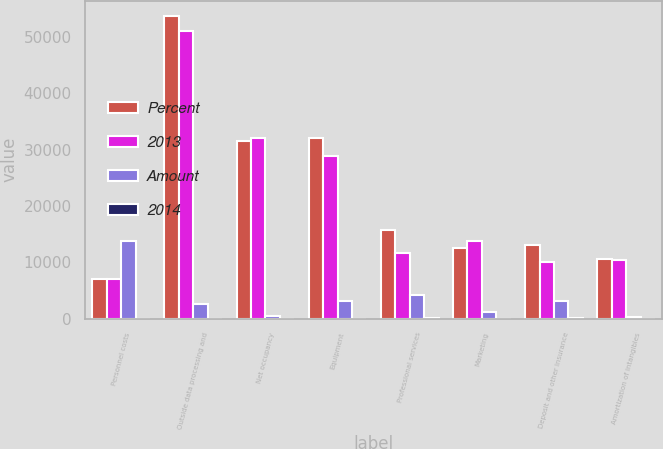Convert chart. <chart><loc_0><loc_0><loc_500><loc_500><stacked_bar_chart><ecel><fcel>Personnel costs<fcel>Outside data processing and<fcel>Net occupancy<fcel>Equipment<fcel>Professional services<fcel>Marketing<fcel>Deposit and other insurance<fcel>Amortization of intangibles<nl><fcel>Percent<fcel>7077<fcel>53685<fcel>31565<fcel>31981<fcel>15665<fcel>12466<fcel>13099<fcel>10653<nl><fcel>2013<fcel>7077<fcel>51071<fcel>31983<fcel>28775<fcel>11567<fcel>13704<fcel>10056<fcel>10320<nl><fcel>Amount<fcel>13735<fcel>2614<fcel>418<fcel>3206<fcel>4098<fcel>1238<fcel>3043<fcel>333<nl><fcel>2014<fcel>6<fcel>5<fcel>1<fcel>11<fcel>35<fcel>9<fcel>30<fcel>3<nl></chart> 